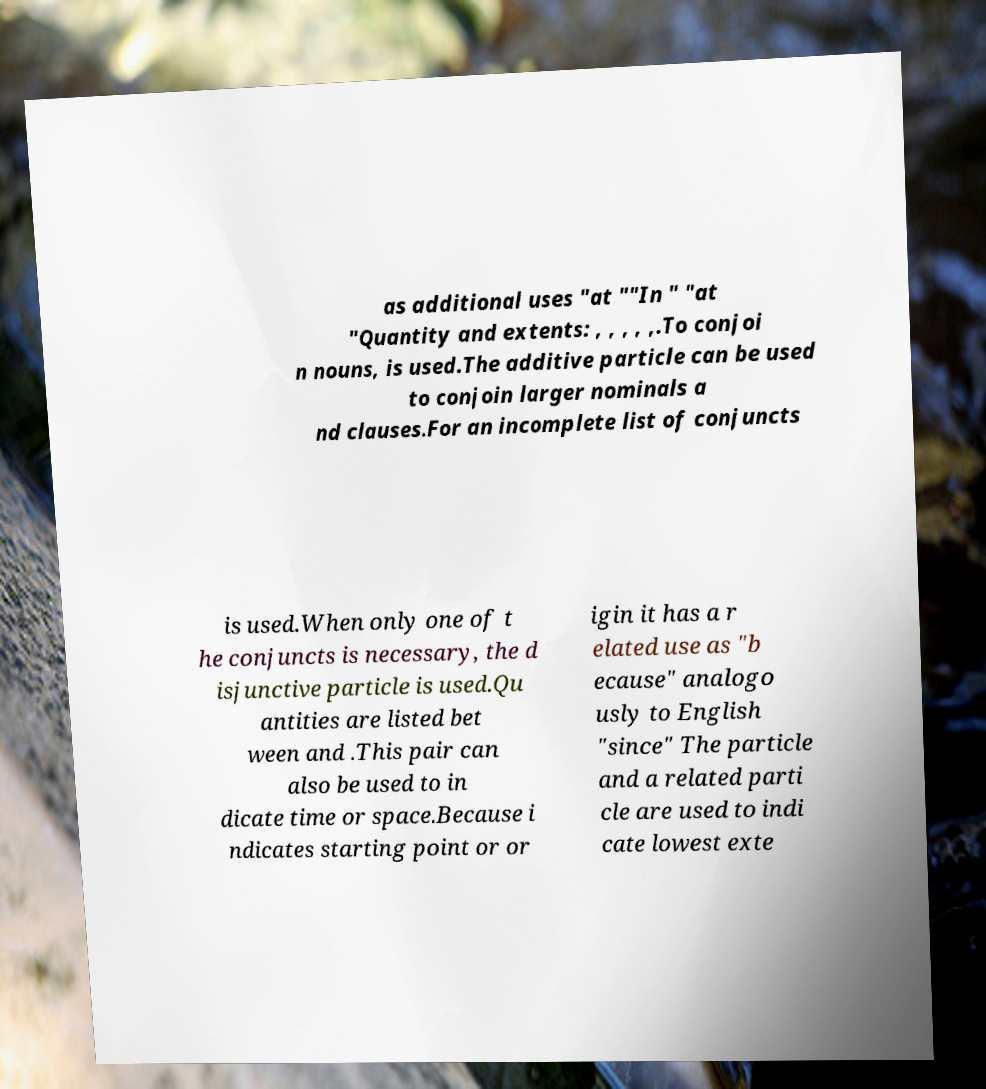Please read and relay the text visible in this image. What does it say? as additional uses "at ""In " "at "Quantity and extents: , , , , ,.To conjoi n nouns, is used.The additive particle can be used to conjoin larger nominals a nd clauses.For an incomplete list of conjuncts is used.When only one of t he conjuncts is necessary, the d isjunctive particle is used.Qu antities are listed bet ween and .This pair can also be used to in dicate time or space.Because i ndicates starting point or or igin it has a r elated use as "b ecause" analogo usly to English "since" The particle and a related parti cle are used to indi cate lowest exte 